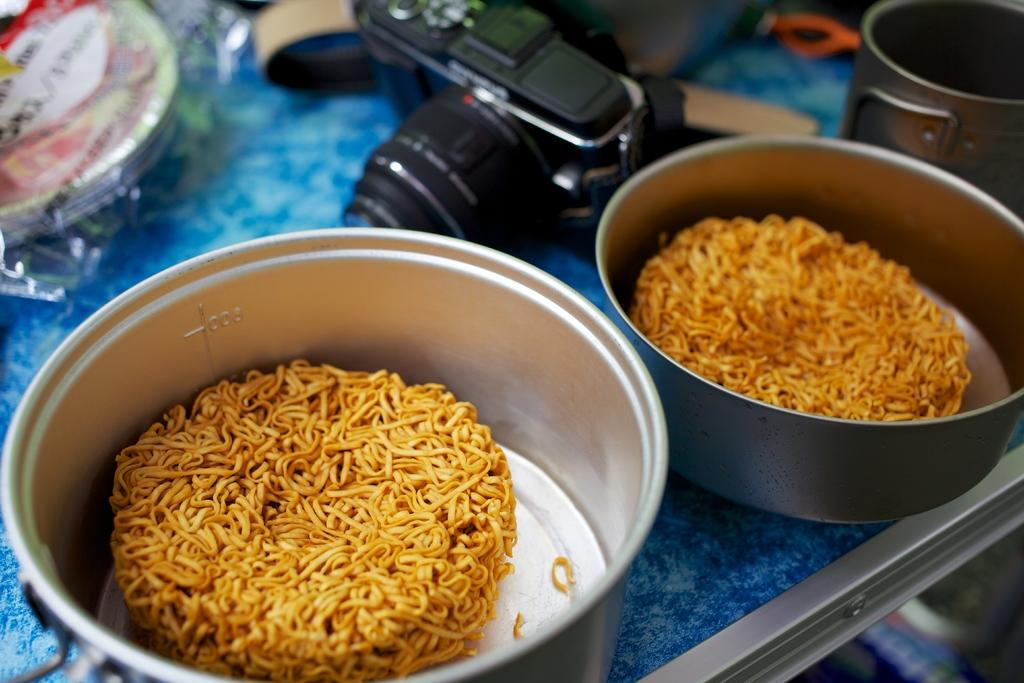What is present in the two bowls on the table? There are food items in the two bowls on the table. What can be used for serving or eating food on the table? There are plates on the table. What device is used for capturing images on the table? There is a camera on the table. What other items are present on the table that are not specified? There are other unspecified items on the table. Can you see a robin using the camera on the table? There is no robin present in the image, and therefore it cannot be using the camera. What type of toy is on the table in the image? There is no toy mentioned or visible in the image. 